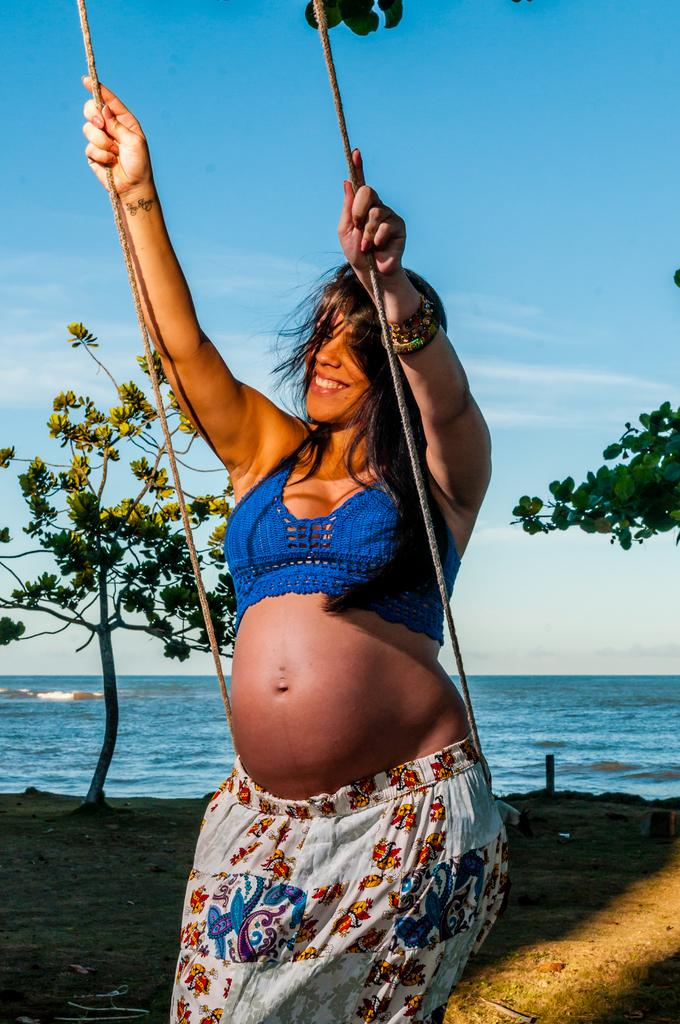Who is present in the image? There is a woman in the image. What is the woman holding in the image? The woman is holding a swing. What can be seen in the background of the image? Trees, water, and the sky are visible in the background. How much news can be seen in the image? There is no news present in the image; it features a woman holding a swing with a background of trees, water, and the sky. 